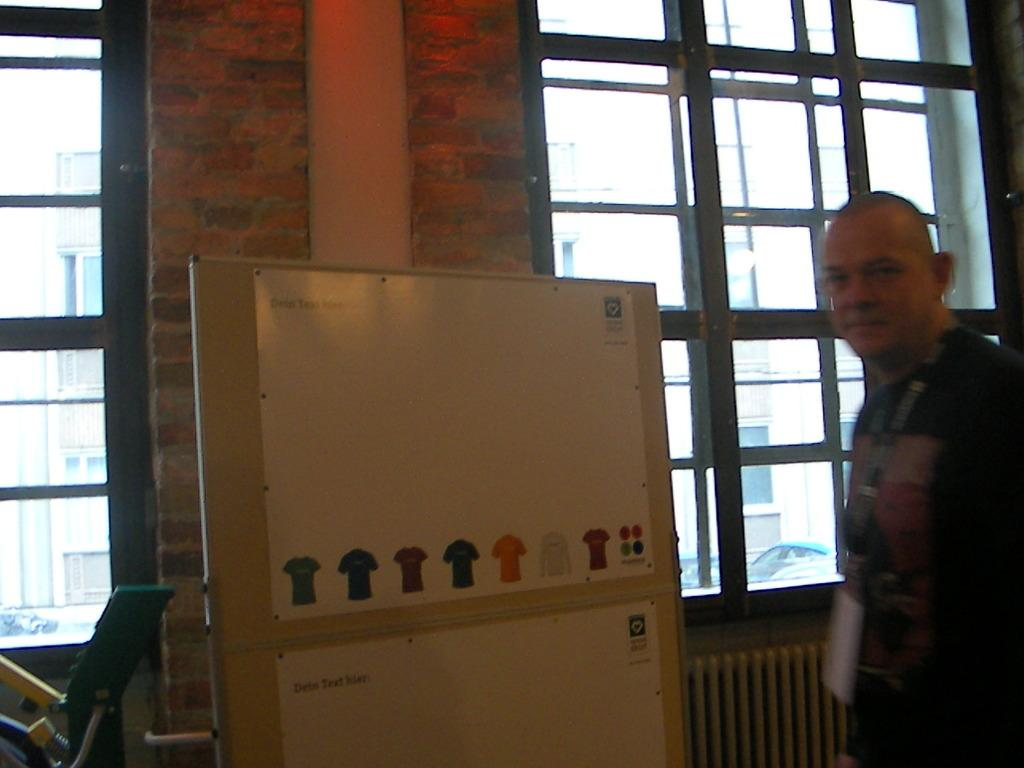What is present in the image? There is a person, a board with images, a wall, windows, a building, and a chair in the image. Can you describe the board with images? The board with images is a notice board or display board with various pictures or illustrations on it. What type of structure is depicted in the image? The image shows a building, which could be an office, school, or any other establishment. How many windows are visible in the image? There are windows present in the image, but the exact number cannot be determined from the provided facts. What is the person in the image doing? The facts do not specify what the person is doing, so we cannot determine their activity from the given information. What type of pan is being used by the person in the image? There is no pan present in the image, and the person's activity is not specified. What is the person's interest in the images on the board? The facts do not mention the person's interest or any interaction with the board, so we cannot determine their interest from the given information. 